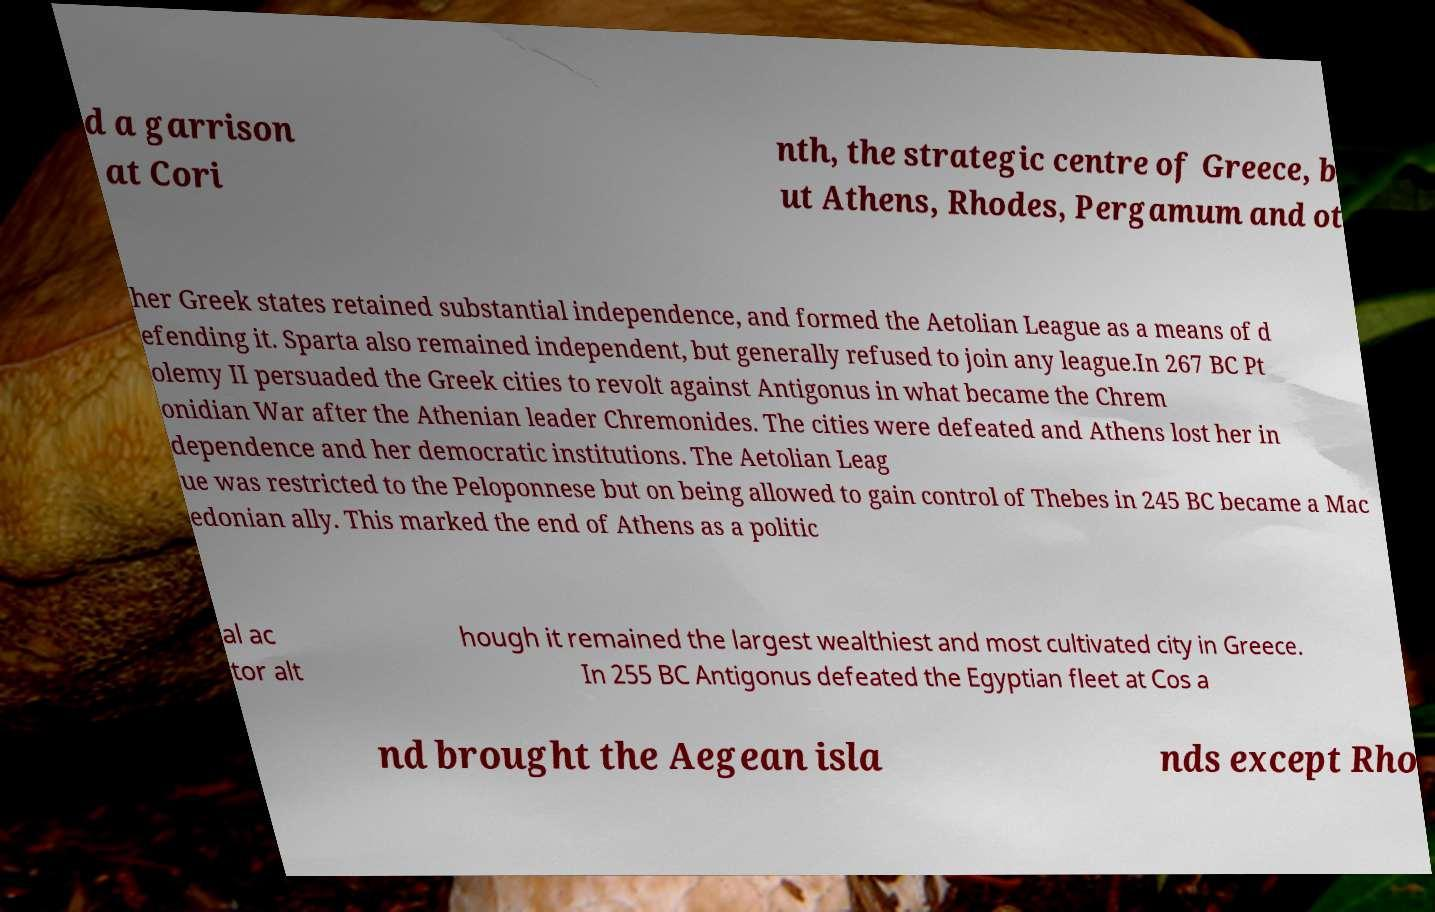Could you assist in decoding the text presented in this image and type it out clearly? d a garrison at Cori nth, the strategic centre of Greece, b ut Athens, Rhodes, Pergamum and ot her Greek states retained substantial independence, and formed the Aetolian League as a means of d efending it. Sparta also remained independent, but generally refused to join any league.In 267 BC Pt olemy II persuaded the Greek cities to revolt against Antigonus in what became the Chrem onidian War after the Athenian leader Chremonides. The cities were defeated and Athens lost her in dependence and her democratic institutions. The Aetolian Leag ue was restricted to the Peloponnese but on being allowed to gain control of Thebes in 245 BC became a Mac edonian ally. This marked the end of Athens as a politic al ac tor alt hough it remained the largest wealthiest and most cultivated city in Greece. In 255 BC Antigonus defeated the Egyptian fleet at Cos a nd brought the Aegean isla nds except Rho 